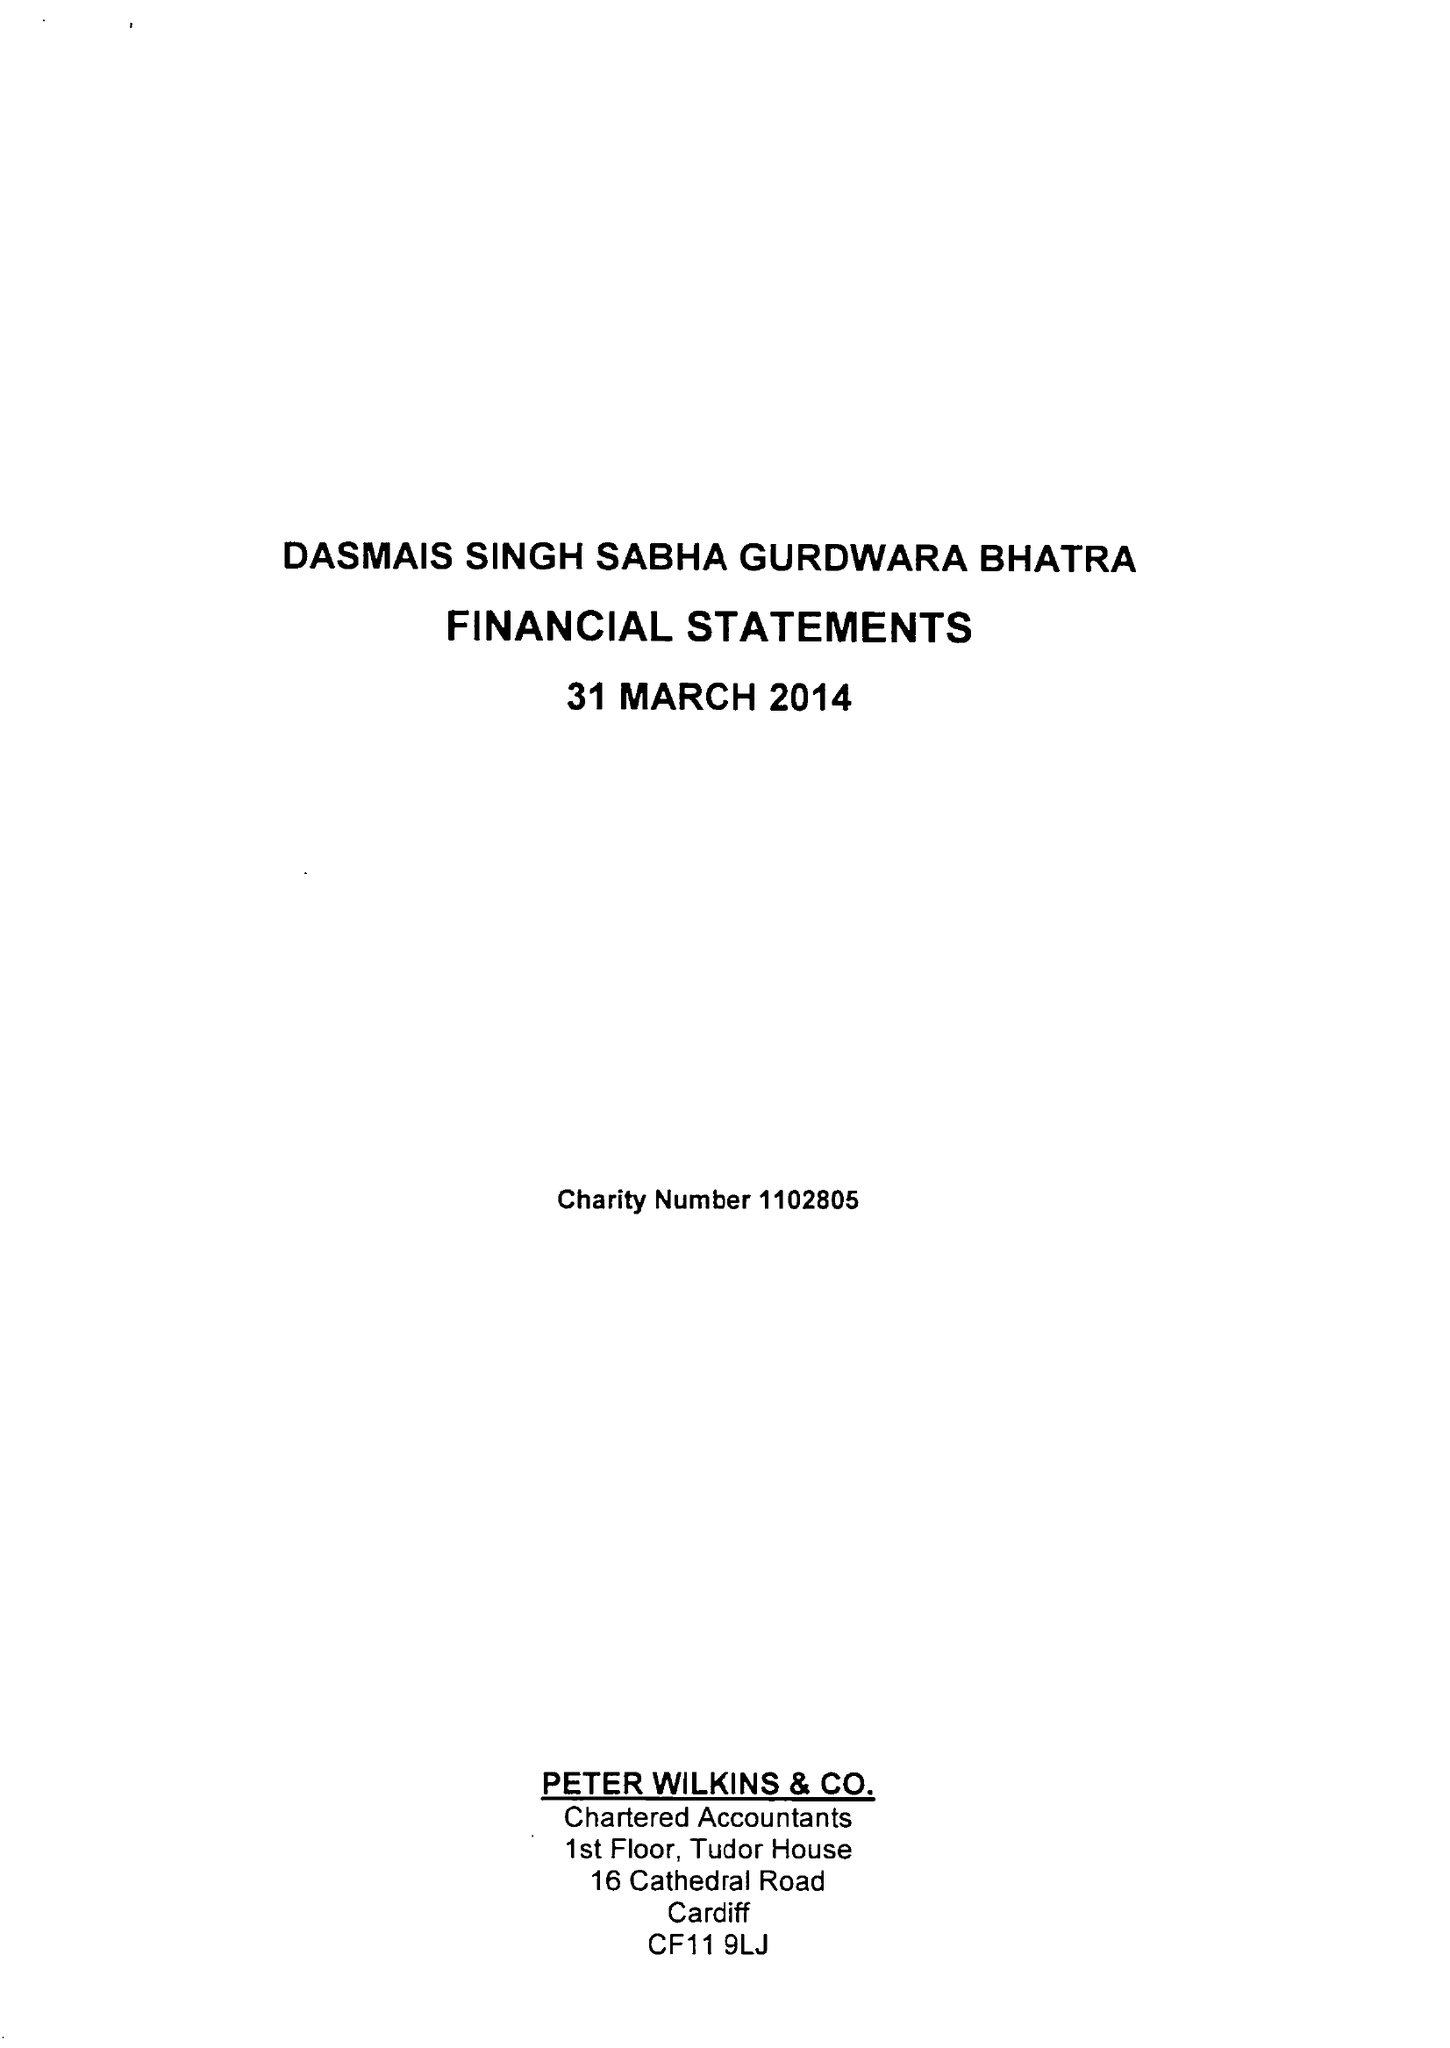What is the value for the address__street_line?
Answer the question using a single word or phrase. 97-99 TUDOR STREET 